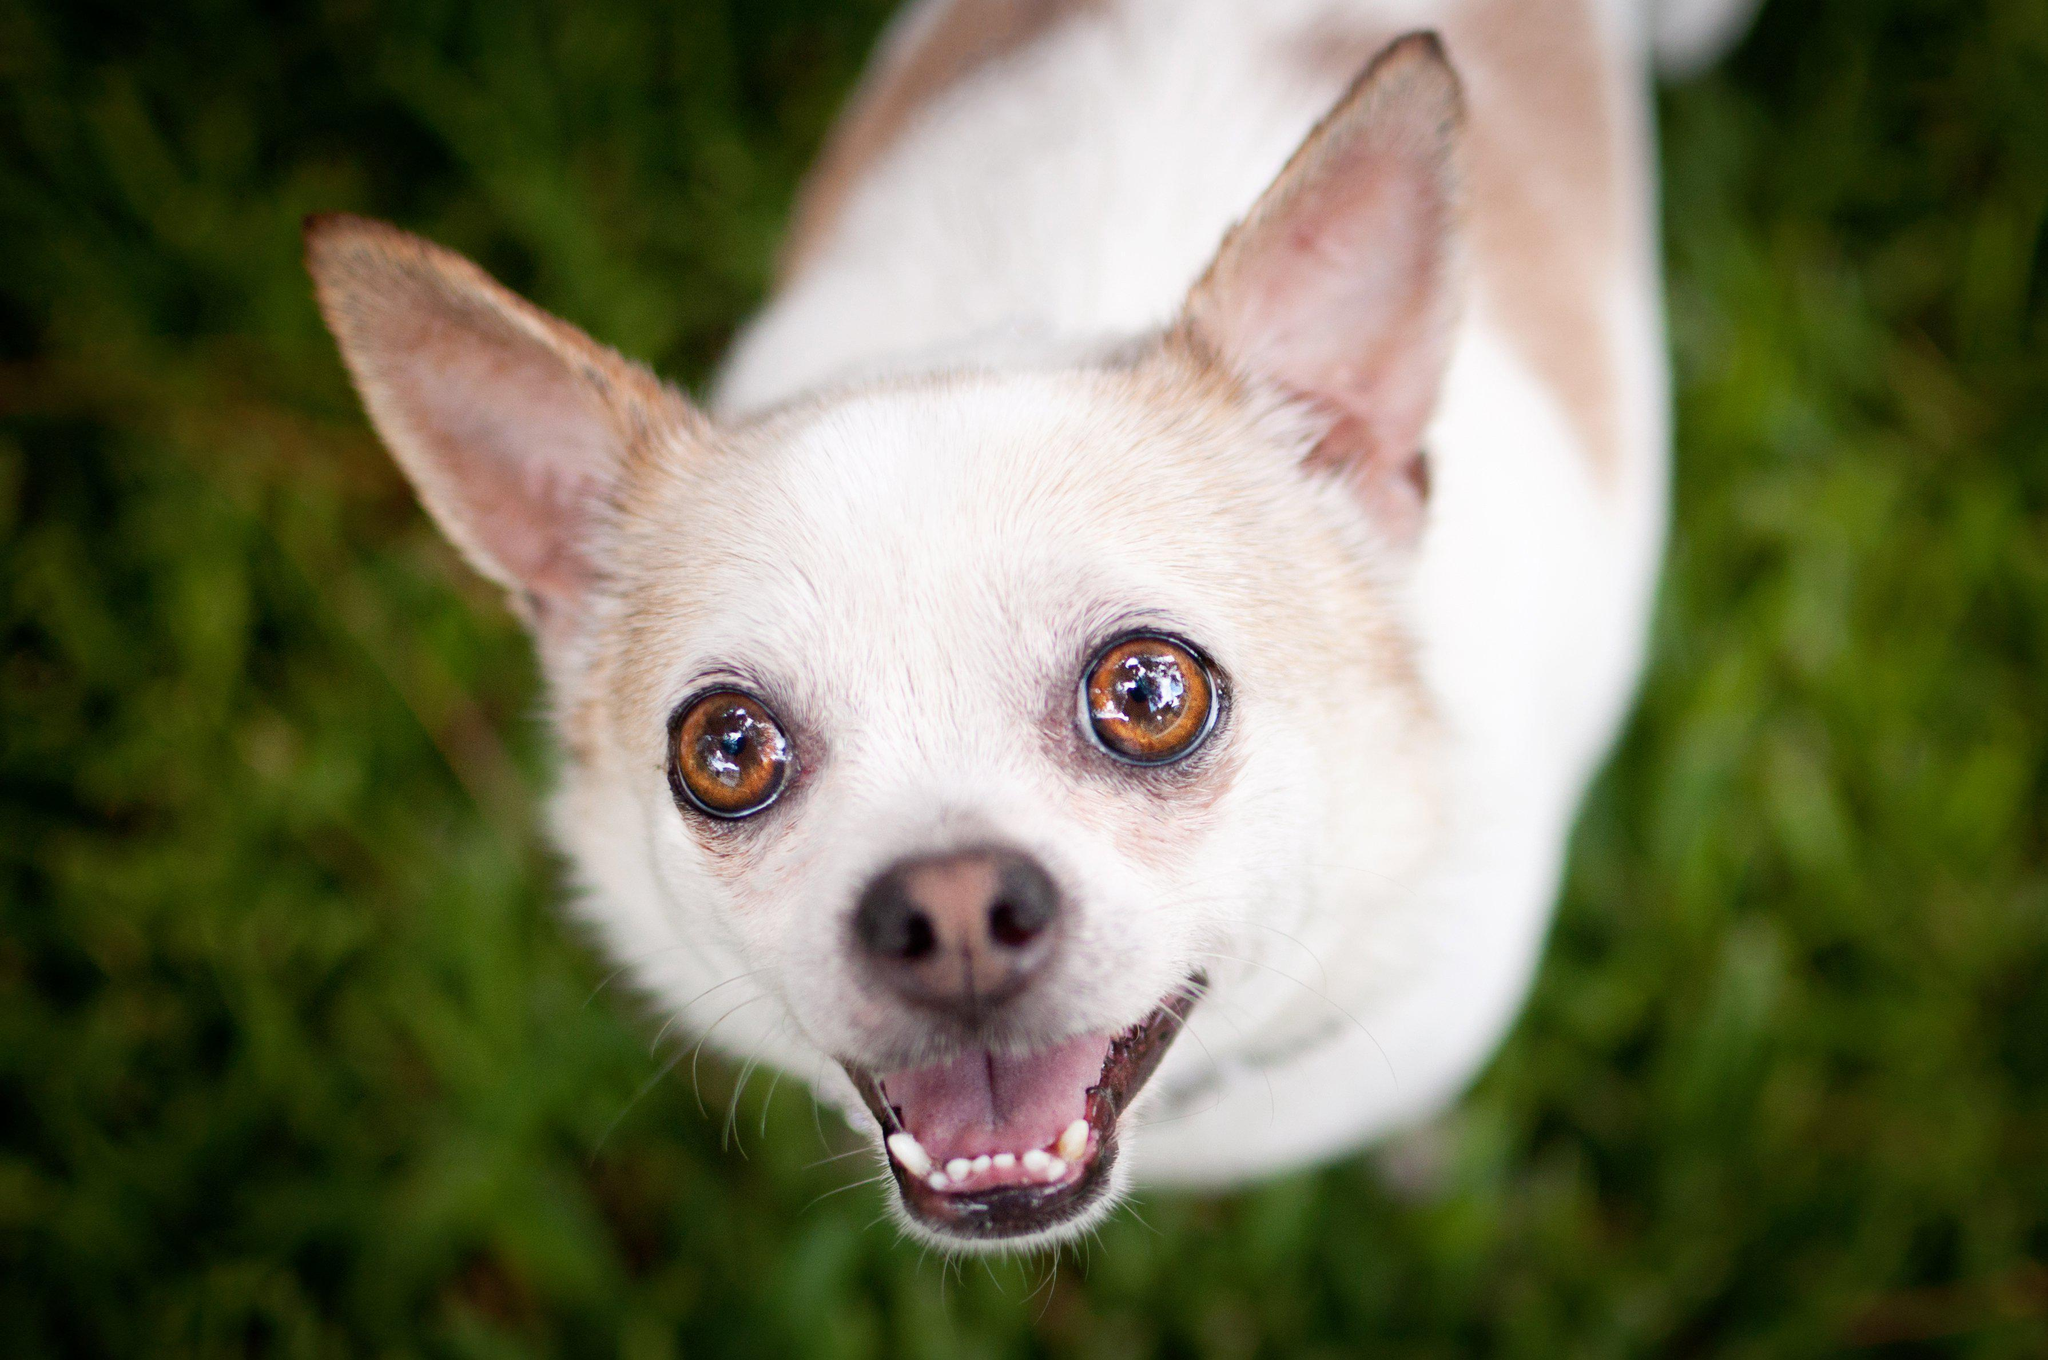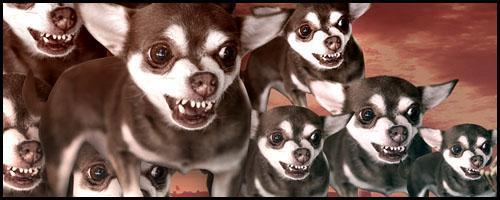The first image is the image on the left, the second image is the image on the right. For the images displayed, is the sentence "A chihuahua is wearing an article of clothing int he right image." factually correct? Answer yes or no. No. The first image is the image on the left, the second image is the image on the right. For the images shown, is this caption "The left image features a fang-bearing chihuahua, and the right image features a chihuhua in costume-like get-up." true? Answer yes or no. No. 